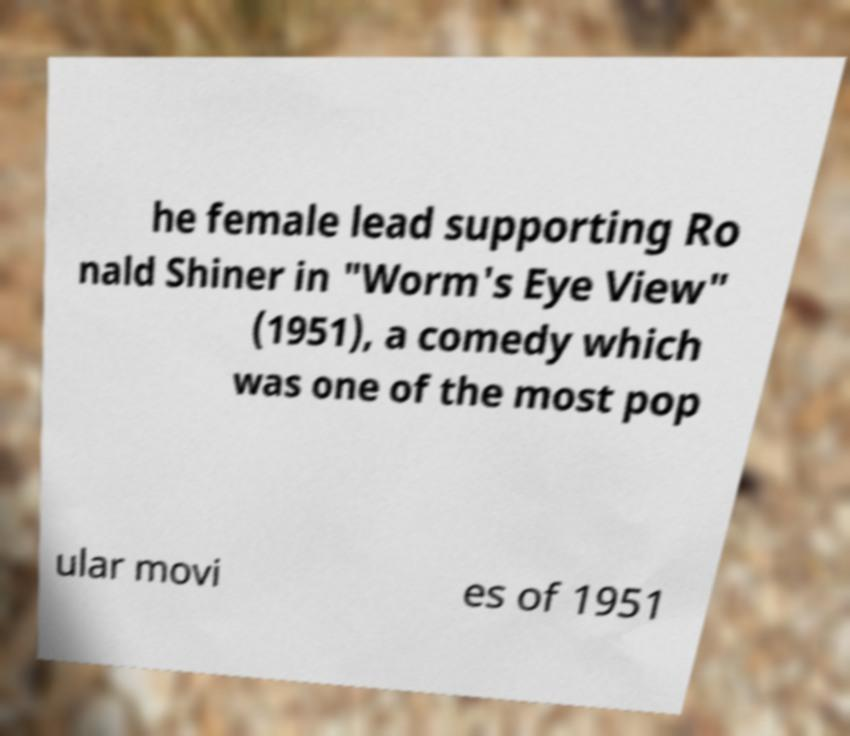Could you extract and type out the text from this image? he female lead supporting Ro nald Shiner in "Worm's Eye View" (1951), a comedy which was one of the most pop ular movi es of 1951 